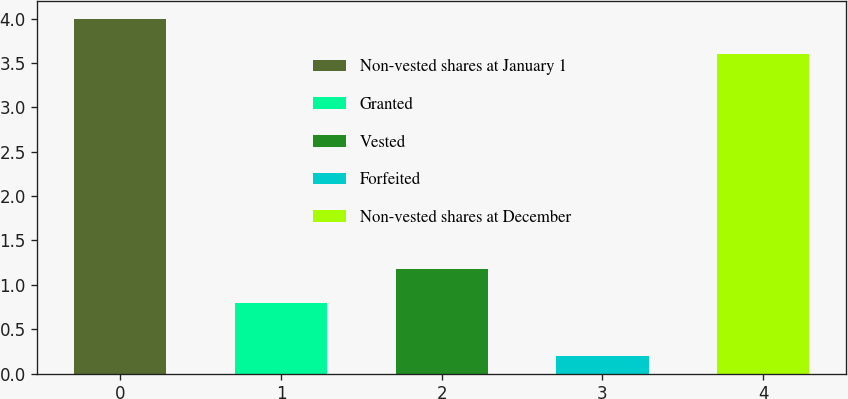<chart> <loc_0><loc_0><loc_500><loc_500><bar_chart><fcel>Non-vested shares at January 1<fcel>Granted<fcel>Vested<fcel>Forfeited<fcel>Non-vested shares at December<nl><fcel>4<fcel>0.8<fcel>1.18<fcel>0.2<fcel>3.6<nl></chart> 